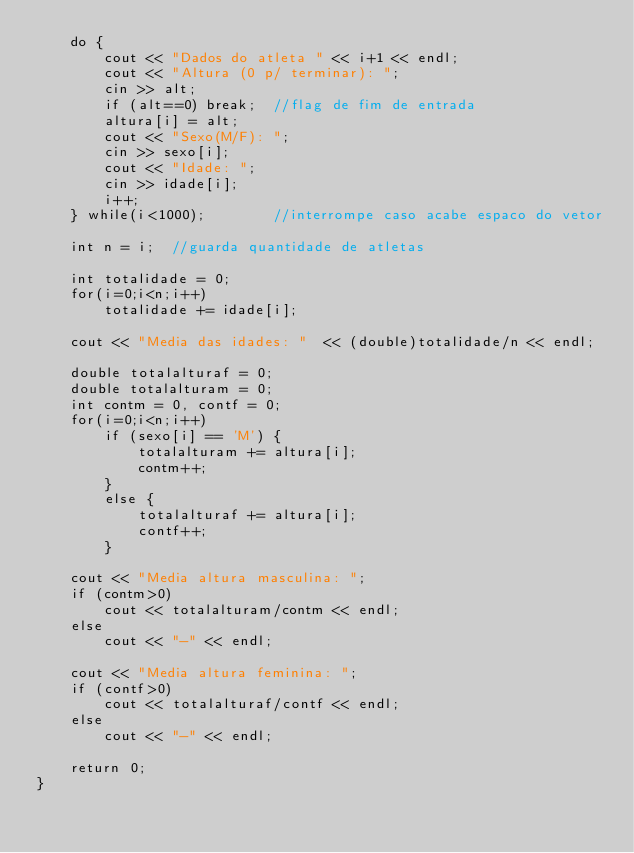Convert code to text. <code><loc_0><loc_0><loc_500><loc_500><_C++_>	do {
		cout << "Dados do atleta " << i+1 << endl;
		cout << "Altura (0 p/ terminar): ";
		cin >> alt;
		if (alt==0) break;	//flag de fim de entrada
		altura[i] = alt;
		cout << "Sexo(M/F): ";
		cin >> sexo[i];
		cout << "Idade: ";
		cin >> idade[i];
		i++;
	} while(i<1000);		//interrompe caso acabe espaco do vetor

	int n = i;	//guarda quantidade de atletas
	
	int totalidade = 0;
	for(i=0;i<n;i++)
		totalidade += idade[i];
	
	cout << "Media das idades: "  << (double)totalidade/n << endl;
	
	double totalalturaf = 0;
	double totalalturam = 0;
	int contm = 0, contf = 0;
	for(i=0;i<n;i++)
		if (sexo[i] == 'M') {
			totalalturam += altura[i];
			contm++;
		}
		else {
			totalalturaf += altura[i];
			contf++;
		}
		
	cout << "Media altura masculina: ";
	if (contm>0)
		cout << totalalturam/contm << endl;
	else
		cout << "-" << endl;
	
	cout << "Media altura feminina: ";
	if (contf>0)
		cout << totalalturaf/contf << endl;
	else
		cout << "-" << endl;
	
	return 0;
}
</code> 